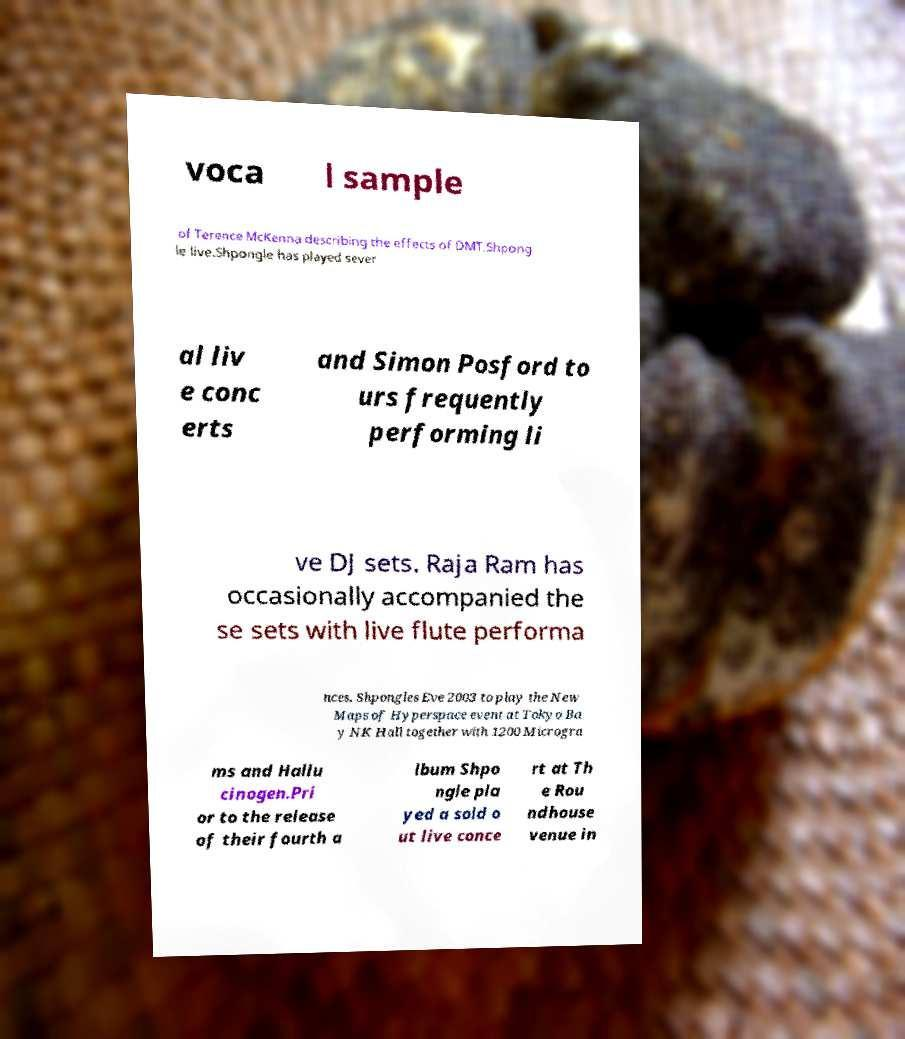Can you accurately transcribe the text from the provided image for me? voca l sample of Terence McKenna describing the effects of DMT.Shpong le live.Shpongle has played sever al liv e conc erts and Simon Posford to urs frequently performing li ve DJ sets. Raja Ram has occasionally accompanied the se sets with live flute performa nces. Shpongles Eve 2003 to play the New Maps of Hyperspace event at Tokyo Ba y NK Hall together with 1200 Microgra ms and Hallu cinogen.Pri or to the release of their fourth a lbum Shpo ngle pla yed a sold o ut live conce rt at Th e Rou ndhouse venue in 